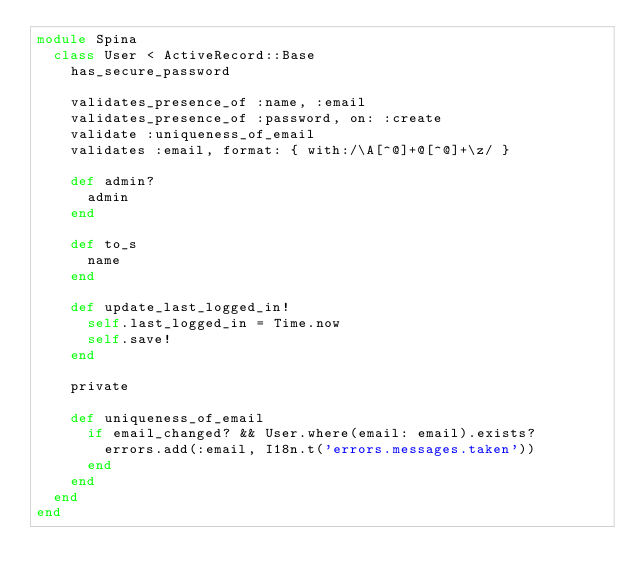Convert code to text. <code><loc_0><loc_0><loc_500><loc_500><_Ruby_>module Spina
  class User < ActiveRecord::Base
    has_secure_password

    validates_presence_of :name, :email
    validates_presence_of :password, on: :create
    validate :uniqueness_of_email
    validates :email, format: { with:/\A[^@]+@[^@]+\z/ }

    def admin?
      admin
    end

    def to_s
      name
    end

    def update_last_logged_in!
      self.last_logged_in = Time.now
      self.save!
    end

    private

    def uniqueness_of_email
      if email_changed? && User.where(email: email).exists?
        errors.add(:email, I18n.t('errors.messages.taken'))
      end
    end
  end
end
</code> 